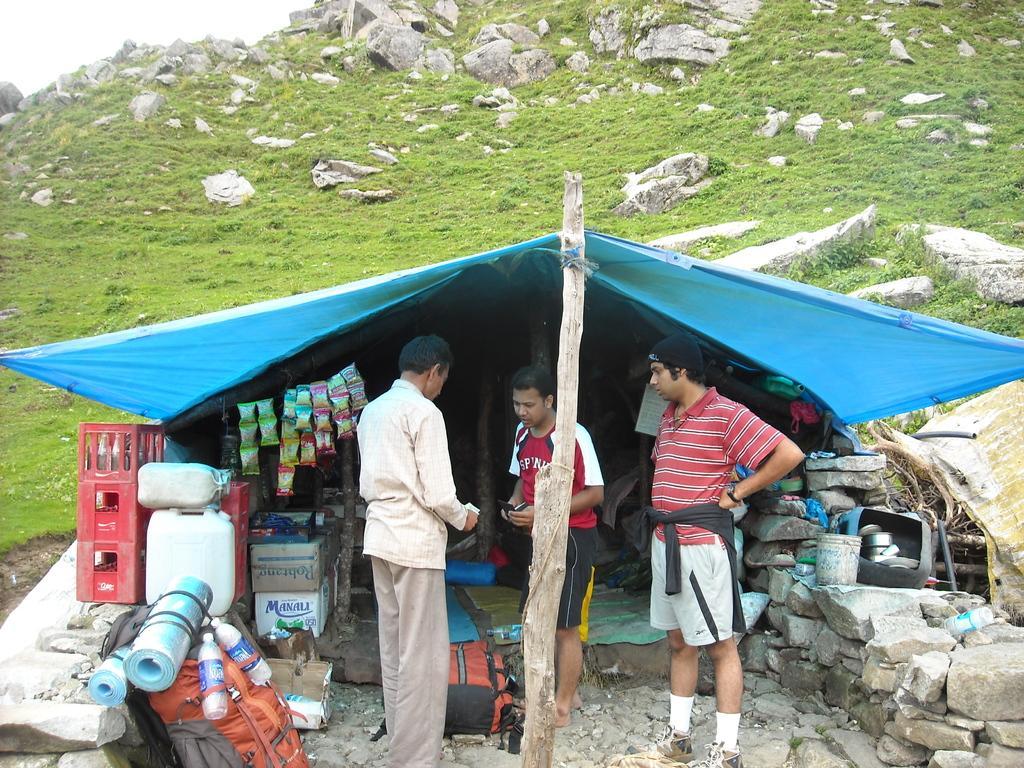Could you give a brief overview of what you see in this image? In this image we can see a shed, we can see a few people standing, beside that we can see a wooden pole. And we can see water bottles, beside that we can see few objects. And we can see the stones and grass, at the top we can see the sky. 